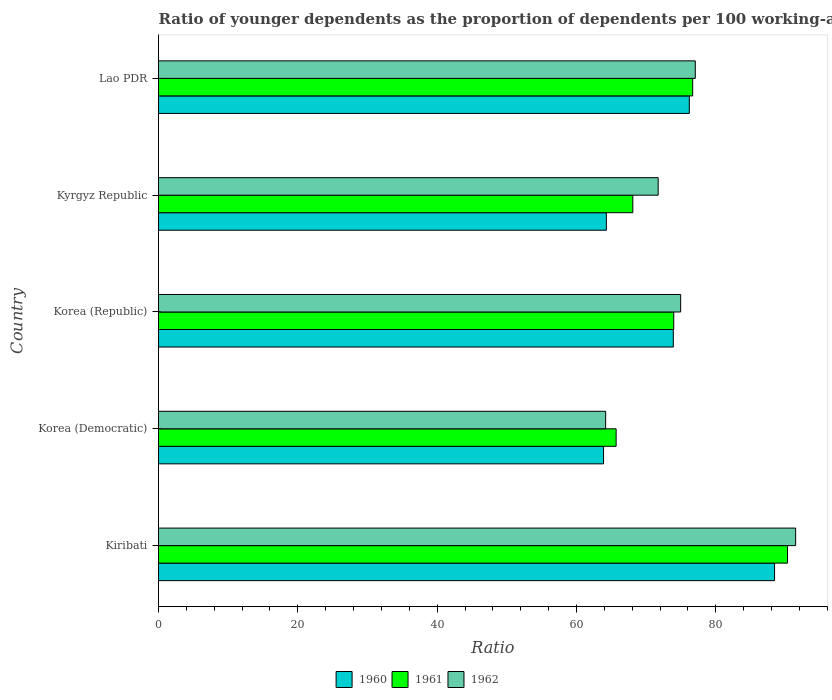How many groups of bars are there?
Make the answer very short. 5. Are the number of bars per tick equal to the number of legend labels?
Your response must be concise. Yes. Are the number of bars on each tick of the Y-axis equal?
Keep it short and to the point. Yes. How many bars are there on the 5th tick from the top?
Provide a succinct answer. 3. What is the label of the 1st group of bars from the top?
Your answer should be very brief. Lao PDR. In how many cases, is the number of bars for a given country not equal to the number of legend labels?
Give a very brief answer. 0. What is the age dependency ratio(young) in 1962 in Kyrgyz Republic?
Give a very brief answer. 71.73. Across all countries, what is the maximum age dependency ratio(young) in 1961?
Provide a short and direct response. 90.3. Across all countries, what is the minimum age dependency ratio(young) in 1961?
Keep it short and to the point. 65.7. In which country was the age dependency ratio(young) in 1962 maximum?
Your answer should be very brief. Kiribati. In which country was the age dependency ratio(young) in 1961 minimum?
Offer a terse response. Korea (Democratic). What is the total age dependency ratio(young) in 1962 in the graph?
Offer a terse response. 379.42. What is the difference between the age dependency ratio(young) in 1960 in Korea (Democratic) and that in Kyrgyz Republic?
Your answer should be very brief. -0.4. What is the difference between the age dependency ratio(young) in 1962 in Kiribati and the age dependency ratio(young) in 1961 in Kyrgyz Republic?
Provide a short and direct response. 23.37. What is the average age dependency ratio(young) in 1962 per country?
Ensure brevity in your answer.  75.88. What is the difference between the age dependency ratio(young) in 1961 and age dependency ratio(young) in 1960 in Lao PDR?
Offer a terse response. 0.48. In how many countries, is the age dependency ratio(young) in 1960 greater than 84 ?
Offer a terse response. 1. What is the ratio of the age dependency ratio(young) in 1960 in Korea (Democratic) to that in Lao PDR?
Your response must be concise. 0.84. Is the age dependency ratio(young) in 1960 in Korea (Democratic) less than that in Korea (Republic)?
Your answer should be very brief. Yes. What is the difference between the highest and the second highest age dependency ratio(young) in 1962?
Provide a succinct answer. 14.41. What is the difference between the highest and the lowest age dependency ratio(young) in 1962?
Give a very brief answer. 27.27. What does the 3rd bar from the bottom in Kyrgyz Republic represents?
Keep it short and to the point. 1962. Is it the case that in every country, the sum of the age dependency ratio(young) in 1961 and age dependency ratio(young) in 1960 is greater than the age dependency ratio(young) in 1962?
Provide a short and direct response. Yes. How many bars are there?
Keep it short and to the point. 15. Are all the bars in the graph horizontal?
Offer a very short reply. Yes. What is the difference between two consecutive major ticks on the X-axis?
Your answer should be compact. 20. Does the graph contain any zero values?
Your answer should be compact. No. Does the graph contain grids?
Offer a terse response. No. Where does the legend appear in the graph?
Give a very brief answer. Bottom center. How many legend labels are there?
Provide a short and direct response. 3. How are the legend labels stacked?
Keep it short and to the point. Horizontal. What is the title of the graph?
Ensure brevity in your answer.  Ratio of younger dependents as the proportion of dependents per 100 working-age population. What is the label or title of the X-axis?
Offer a very short reply. Ratio. What is the label or title of the Y-axis?
Provide a short and direct response. Country. What is the Ratio of 1960 in Kiribati?
Make the answer very short. 88.44. What is the Ratio of 1961 in Kiribati?
Your answer should be very brief. 90.3. What is the Ratio in 1962 in Kiribati?
Give a very brief answer. 91.47. What is the Ratio of 1960 in Korea (Democratic)?
Keep it short and to the point. 63.89. What is the Ratio in 1961 in Korea (Democratic)?
Offer a terse response. 65.7. What is the Ratio of 1962 in Korea (Democratic)?
Make the answer very short. 64.19. What is the Ratio in 1960 in Korea (Republic)?
Give a very brief answer. 73.91. What is the Ratio in 1961 in Korea (Republic)?
Your answer should be compact. 73.97. What is the Ratio in 1962 in Korea (Republic)?
Offer a very short reply. 74.96. What is the Ratio of 1960 in Kyrgyz Republic?
Your answer should be very brief. 64.29. What is the Ratio of 1961 in Kyrgyz Republic?
Offer a terse response. 68.1. What is the Ratio of 1962 in Kyrgyz Republic?
Make the answer very short. 71.73. What is the Ratio in 1960 in Lao PDR?
Provide a succinct answer. 76.2. What is the Ratio in 1961 in Lao PDR?
Your response must be concise. 76.69. What is the Ratio of 1962 in Lao PDR?
Ensure brevity in your answer.  77.06. Across all countries, what is the maximum Ratio in 1960?
Your answer should be very brief. 88.44. Across all countries, what is the maximum Ratio in 1961?
Your answer should be compact. 90.3. Across all countries, what is the maximum Ratio of 1962?
Ensure brevity in your answer.  91.47. Across all countries, what is the minimum Ratio of 1960?
Keep it short and to the point. 63.89. Across all countries, what is the minimum Ratio of 1961?
Your answer should be compact. 65.7. Across all countries, what is the minimum Ratio of 1962?
Ensure brevity in your answer.  64.19. What is the total Ratio in 1960 in the graph?
Offer a very short reply. 366.74. What is the total Ratio in 1961 in the graph?
Offer a very short reply. 374.75. What is the total Ratio of 1962 in the graph?
Provide a succinct answer. 379.42. What is the difference between the Ratio in 1960 in Kiribati and that in Korea (Democratic)?
Your response must be concise. 24.55. What is the difference between the Ratio in 1961 in Kiribati and that in Korea (Democratic)?
Make the answer very short. 24.61. What is the difference between the Ratio of 1962 in Kiribati and that in Korea (Democratic)?
Offer a very short reply. 27.27. What is the difference between the Ratio in 1960 in Kiribati and that in Korea (Republic)?
Your answer should be very brief. 14.54. What is the difference between the Ratio in 1961 in Kiribati and that in Korea (Republic)?
Your response must be concise. 16.34. What is the difference between the Ratio of 1962 in Kiribati and that in Korea (Republic)?
Provide a short and direct response. 16.51. What is the difference between the Ratio in 1960 in Kiribati and that in Kyrgyz Republic?
Your answer should be very brief. 24.15. What is the difference between the Ratio in 1961 in Kiribati and that in Kyrgyz Republic?
Ensure brevity in your answer.  22.21. What is the difference between the Ratio in 1962 in Kiribati and that in Kyrgyz Republic?
Give a very brief answer. 19.73. What is the difference between the Ratio in 1960 in Kiribati and that in Lao PDR?
Your answer should be very brief. 12.24. What is the difference between the Ratio of 1961 in Kiribati and that in Lao PDR?
Offer a terse response. 13.62. What is the difference between the Ratio in 1962 in Kiribati and that in Lao PDR?
Your response must be concise. 14.41. What is the difference between the Ratio of 1960 in Korea (Democratic) and that in Korea (Republic)?
Give a very brief answer. -10.02. What is the difference between the Ratio in 1961 in Korea (Democratic) and that in Korea (Republic)?
Provide a succinct answer. -8.27. What is the difference between the Ratio in 1962 in Korea (Democratic) and that in Korea (Republic)?
Provide a short and direct response. -10.77. What is the difference between the Ratio in 1960 in Korea (Democratic) and that in Kyrgyz Republic?
Provide a succinct answer. -0.4. What is the difference between the Ratio in 1961 in Korea (Democratic) and that in Kyrgyz Republic?
Offer a terse response. -2.4. What is the difference between the Ratio of 1962 in Korea (Democratic) and that in Kyrgyz Republic?
Provide a short and direct response. -7.54. What is the difference between the Ratio in 1960 in Korea (Democratic) and that in Lao PDR?
Provide a short and direct response. -12.31. What is the difference between the Ratio in 1961 in Korea (Democratic) and that in Lao PDR?
Offer a terse response. -10.99. What is the difference between the Ratio in 1962 in Korea (Democratic) and that in Lao PDR?
Offer a very short reply. -12.87. What is the difference between the Ratio in 1960 in Korea (Republic) and that in Kyrgyz Republic?
Ensure brevity in your answer.  9.61. What is the difference between the Ratio of 1961 in Korea (Republic) and that in Kyrgyz Republic?
Your answer should be very brief. 5.87. What is the difference between the Ratio in 1962 in Korea (Republic) and that in Kyrgyz Republic?
Keep it short and to the point. 3.23. What is the difference between the Ratio of 1960 in Korea (Republic) and that in Lao PDR?
Your response must be concise. -2.3. What is the difference between the Ratio of 1961 in Korea (Republic) and that in Lao PDR?
Keep it short and to the point. -2.72. What is the difference between the Ratio in 1962 in Korea (Republic) and that in Lao PDR?
Provide a succinct answer. -2.1. What is the difference between the Ratio in 1960 in Kyrgyz Republic and that in Lao PDR?
Offer a very short reply. -11.91. What is the difference between the Ratio in 1961 in Kyrgyz Republic and that in Lao PDR?
Offer a very short reply. -8.59. What is the difference between the Ratio of 1962 in Kyrgyz Republic and that in Lao PDR?
Give a very brief answer. -5.33. What is the difference between the Ratio in 1960 in Kiribati and the Ratio in 1961 in Korea (Democratic)?
Your answer should be very brief. 22.75. What is the difference between the Ratio of 1960 in Kiribati and the Ratio of 1962 in Korea (Democratic)?
Your response must be concise. 24.25. What is the difference between the Ratio of 1961 in Kiribati and the Ratio of 1962 in Korea (Democratic)?
Offer a terse response. 26.11. What is the difference between the Ratio in 1960 in Kiribati and the Ratio in 1961 in Korea (Republic)?
Provide a succinct answer. 14.47. What is the difference between the Ratio in 1960 in Kiribati and the Ratio in 1962 in Korea (Republic)?
Give a very brief answer. 13.48. What is the difference between the Ratio in 1961 in Kiribati and the Ratio in 1962 in Korea (Republic)?
Make the answer very short. 15.34. What is the difference between the Ratio in 1960 in Kiribati and the Ratio in 1961 in Kyrgyz Republic?
Offer a terse response. 20.35. What is the difference between the Ratio of 1960 in Kiribati and the Ratio of 1962 in Kyrgyz Republic?
Ensure brevity in your answer.  16.71. What is the difference between the Ratio of 1961 in Kiribati and the Ratio of 1962 in Kyrgyz Republic?
Your response must be concise. 18.57. What is the difference between the Ratio of 1960 in Kiribati and the Ratio of 1961 in Lao PDR?
Offer a very short reply. 11.75. What is the difference between the Ratio of 1960 in Kiribati and the Ratio of 1962 in Lao PDR?
Keep it short and to the point. 11.38. What is the difference between the Ratio in 1961 in Kiribati and the Ratio in 1962 in Lao PDR?
Provide a succinct answer. 13.24. What is the difference between the Ratio of 1960 in Korea (Democratic) and the Ratio of 1961 in Korea (Republic)?
Your answer should be compact. -10.08. What is the difference between the Ratio of 1960 in Korea (Democratic) and the Ratio of 1962 in Korea (Republic)?
Your answer should be compact. -11.07. What is the difference between the Ratio in 1961 in Korea (Democratic) and the Ratio in 1962 in Korea (Republic)?
Your answer should be compact. -9.26. What is the difference between the Ratio in 1960 in Korea (Democratic) and the Ratio in 1961 in Kyrgyz Republic?
Offer a very short reply. -4.2. What is the difference between the Ratio in 1960 in Korea (Democratic) and the Ratio in 1962 in Kyrgyz Republic?
Your answer should be compact. -7.84. What is the difference between the Ratio in 1961 in Korea (Democratic) and the Ratio in 1962 in Kyrgyz Republic?
Your answer should be very brief. -6.04. What is the difference between the Ratio in 1960 in Korea (Democratic) and the Ratio in 1961 in Lao PDR?
Your answer should be very brief. -12.8. What is the difference between the Ratio of 1960 in Korea (Democratic) and the Ratio of 1962 in Lao PDR?
Offer a very short reply. -13.17. What is the difference between the Ratio of 1961 in Korea (Democratic) and the Ratio of 1962 in Lao PDR?
Give a very brief answer. -11.37. What is the difference between the Ratio in 1960 in Korea (Republic) and the Ratio in 1961 in Kyrgyz Republic?
Offer a terse response. 5.81. What is the difference between the Ratio in 1960 in Korea (Republic) and the Ratio in 1962 in Kyrgyz Republic?
Offer a terse response. 2.17. What is the difference between the Ratio in 1961 in Korea (Republic) and the Ratio in 1962 in Kyrgyz Republic?
Offer a terse response. 2.24. What is the difference between the Ratio of 1960 in Korea (Republic) and the Ratio of 1961 in Lao PDR?
Your answer should be very brief. -2.78. What is the difference between the Ratio in 1960 in Korea (Republic) and the Ratio in 1962 in Lao PDR?
Your response must be concise. -3.16. What is the difference between the Ratio in 1961 in Korea (Republic) and the Ratio in 1962 in Lao PDR?
Ensure brevity in your answer.  -3.09. What is the difference between the Ratio in 1960 in Kyrgyz Republic and the Ratio in 1961 in Lao PDR?
Your answer should be very brief. -12.4. What is the difference between the Ratio in 1960 in Kyrgyz Republic and the Ratio in 1962 in Lao PDR?
Offer a very short reply. -12.77. What is the difference between the Ratio of 1961 in Kyrgyz Republic and the Ratio of 1962 in Lao PDR?
Offer a very short reply. -8.97. What is the average Ratio of 1960 per country?
Offer a very short reply. 73.35. What is the average Ratio of 1961 per country?
Provide a succinct answer. 74.95. What is the average Ratio of 1962 per country?
Offer a very short reply. 75.88. What is the difference between the Ratio in 1960 and Ratio in 1961 in Kiribati?
Provide a short and direct response. -1.86. What is the difference between the Ratio of 1960 and Ratio of 1962 in Kiribati?
Make the answer very short. -3.02. What is the difference between the Ratio of 1961 and Ratio of 1962 in Kiribati?
Give a very brief answer. -1.16. What is the difference between the Ratio of 1960 and Ratio of 1961 in Korea (Democratic)?
Your answer should be very brief. -1.81. What is the difference between the Ratio in 1960 and Ratio in 1962 in Korea (Democratic)?
Offer a terse response. -0.3. What is the difference between the Ratio of 1961 and Ratio of 1962 in Korea (Democratic)?
Your answer should be compact. 1.5. What is the difference between the Ratio of 1960 and Ratio of 1961 in Korea (Republic)?
Offer a terse response. -0.06. What is the difference between the Ratio in 1960 and Ratio in 1962 in Korea (Republic)?
Your answer should be compact. -1.05. What is the difference between the Ratio in 1961 and Ratio in 1962 in Korea (Republic)?
Ensure brevity in your answer.  -0.99. What is the difference between the Ratio in 1960 and Ratio in 1961 in Kyrgyz Republic?
Offer a very short reply. -3.8. What is the difference between the Ratio in 1960 and Ratio in 1962 in Kyrgyz Republic?
Offer a terse response. -7.44. What is the difference between the Ratio of 1961 and Ratio of 1962 in Kyrgyz Republic?
Make the answer very short. -3.64. What is the difference between the Ratio in 1960 and Ratio in 1961 in Lao PDR?
Make the answer very short. -0.48. What is the difference between the Ratio in 1960 and Ratio in 1962 in Lao PDR?
Give a very brief answer. -0.86. What is the difference between the Ratio in 1961 and Ratio in 1962 in Lao PDR?
Make the answer very short. -0.37. What is the ratio of the Ratio in 1960 in Kiribati to that in Korea (Democratic)?
Keep it short and to the point. 1.38. What is the ratio of the Ratio in 1961 in Kiribati to that in Korea (Democratic)?
Make the answer very short. 1.37. What is the ratio of the Ratio of 1962 in Kiribati to that in Korea (Democratic)?
Your answer should be compact. 1.42. What is the ratio of the Ratio in 1960 in Kiribati to that in Korea (Republic)?
Keep it short and to the point. 1.2. What is the ratio of the Ratio of 1961 in Kiribati to that in Korea (Republic)?
Make the answer very short. 1.22. What is the ratio of the Ratio of 1962 in Kiribati to that in Korea (Republic)?
Make the answer very short. 1.22. What is the ratio of the Ratio in 1960 in Kiribati to that in Kyrgyz Republic?
Your answer should be compact. 1.38. What is the ratio of the Ratio of 1961 in Kiribati to that in Kyrgyz Republic?
Your answer should be very brief. 1.33. What is the ratio of the Ratio of 1962 in Kiribati to that in Kyrgyz Republic?
Your response must be concise. 1.28. What is the ratio of the Ratio of 1960 in Kiribati to that in Lao PDR?
Your answer should be very brief. 1.16. What is the ratio of the Ratio of 1961 in Kiribati to that in Lao PDR?
Your answer should be compact. 1.18. What is the ratio of the Ratio of 1962 in Kiribati to that in Lao PDR?
Provide a short and direct response. 1.19. What is the ratio of the Ratio of 1960 in Korea (Democratic) to that in Korea (Republic)?
Offer a terse response. 0.86. What is the ratio of the Ratio in 1961 in Korea (Democratic) to that in Korea (Republic)?
Offer a terse response. 0.89. What is the ratio of the Ratio of 1962 in Korea (Democratic) to that in Korea (Republic)?
Provide a short and direct response. 0.86. What is the ratio of the Ratio of 1960 in Korea (Democratic) to that in Kyrgyz Republic?
Make the answer very short. 0.99. What is the ratio of the Ratio in 1961 in Korea (Democratic) to that in Kyrgyz Republic?
Ensure brevity in your answer.  0.96. What is the ratio of the Ratio in 1962 in Korea (Democratic) to that in Kyrgyz Republic?
Give a very brief answer. 0.89. What is the ratio of the Ratio of 1960 in Korea (Democratic) to that in Lao PDR?
Offer a very short reply. 0.84. What is the ratio of the Ratio in 1961 in Korea (Democratic) to that in Lao PDR?
Offer a very short reply. 0.86. What is the ratio of the Ratio of 1962 in Korea (Democratic) to that in Lao PDR?
Your response must be concise. 0.83. What is the ratio of the Ratio of 1960 in Korea (Republic) to that in Kyrgyz Republic?
Ensure brevity in your answer.  1.15. What is the ratio of the Ratio of 1961 in Korea (Republic) to that in Kyrgyz Republic?
Provide a succinct answer. 1.09. What is the ratio of the Ratio of 1962 in Korea (Republic) to that in Kyrgyz Republic?
Provide a short and direct response. 1.04. What is the ratio of the Ratio of 1960 in Korea (Republic) to that in Lao PDR?
Your answer should be very brief. 0.97. What is the ratio of the Ratio of 1961 in Korea (Republic) to that in Lao PDR?
Provide a short and direct response. 0.96. What is the ratio of the Ratio in 1962 in Korea (Republic) to that in Lao PDR?
Your response must be concise. 0.97. What is the ratio of the Ratio of 1960 in Kyrgyz Republic to that in Lao PDR?
Your answer should be compact. 0.84. What is the ratio of the Ratio of 1961 in Kyrgyz Republic to that in Lao PDR?
Provide a succinct answer. 0.89. What is the ratio of the Ratio in 1962 in Kyrgyz Republic to that in Lao PDR?
Your answer should be compact. 0.93. What is the difference between the highest and the second highest Ratio in 1960?
Your response must be concise. 12.24. What is the difference between the highest and the second highest Ratio of 1961?
Give a very brief answer. 13.62. What is the difference between the highest and the second highest Ratio in 1962?
Provide a succinct answer. 14.41. What is the difference between the highest and the lowest Ratio in 1960?
Your response must be concise. 24.55. What is the difference between the highest and the lowest Ratio of 1961?
Provide a succinct answer. 24.61. What is the difference between the highest and the lowest Ratio in 1962?
Your response must be concise. 27.27. 